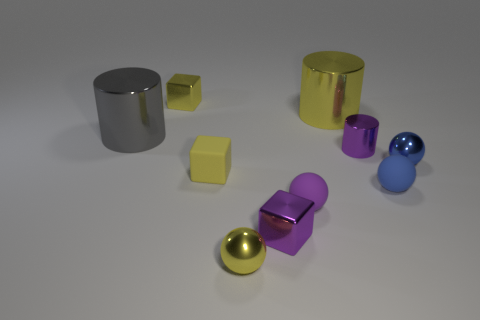What time of day does this scene represent, and what kind of lighting is being used? The scene appears to be artificially lit with soft shadows suggesting an indoor setting with diffused lighting, rather than a specific time of day. It could be studio lighting designed to create a neutral environment to highlight the objects. 